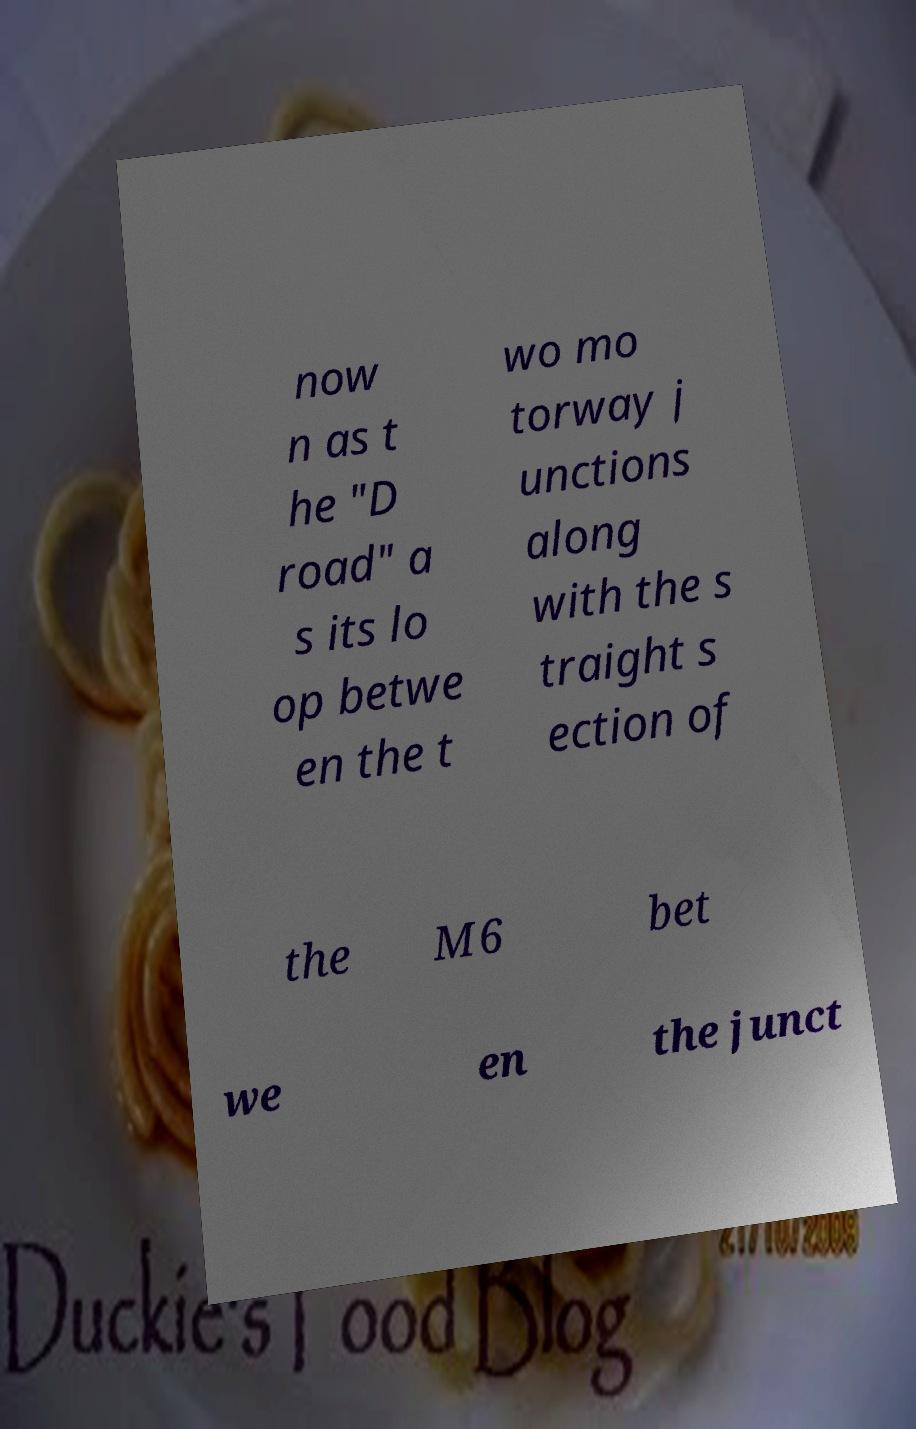What messages or text are displayed in this image? I need them in a readable, typed format. now n as t he "D road" a s its lo op betwe en the t wo mo torway j unctions along with the s traight s ection of the M6 bet we en the junct 